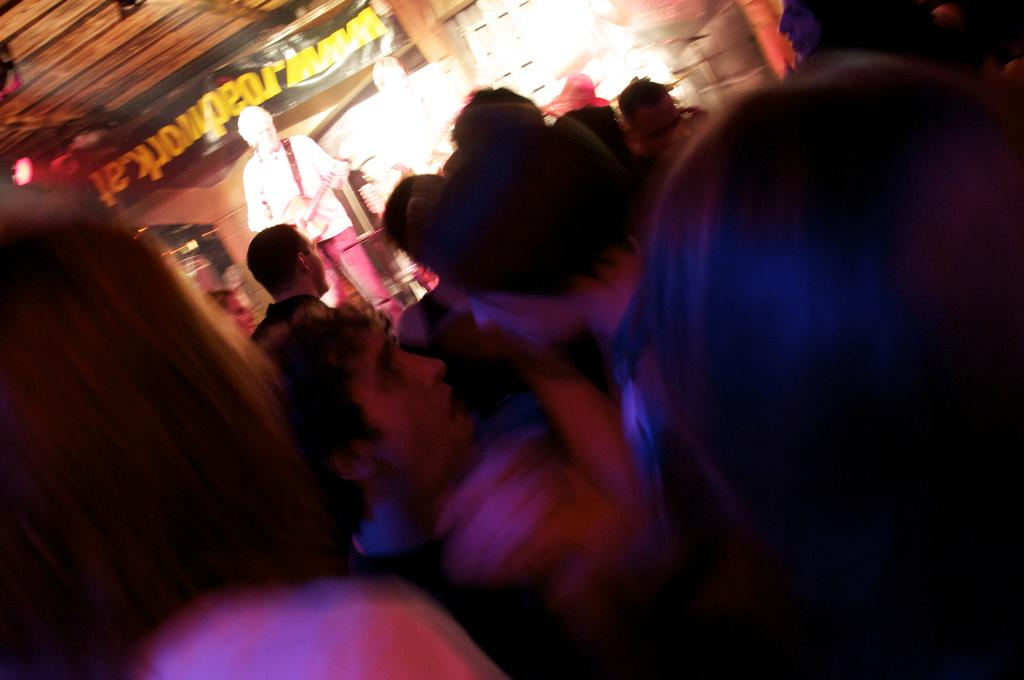How many people are in the image? There is a group of people in the image. What is one person doing in the image? A person is holding a guitar. What can be seen in the background of the image? There is a banner in the background of the image, and there are objects visible as well. What type of animal is tied to the guitar in the image? There is no animal tied to the guitar in the image. How much debt does the person holding the guitar have in the image? There is no information about debt in the image. 